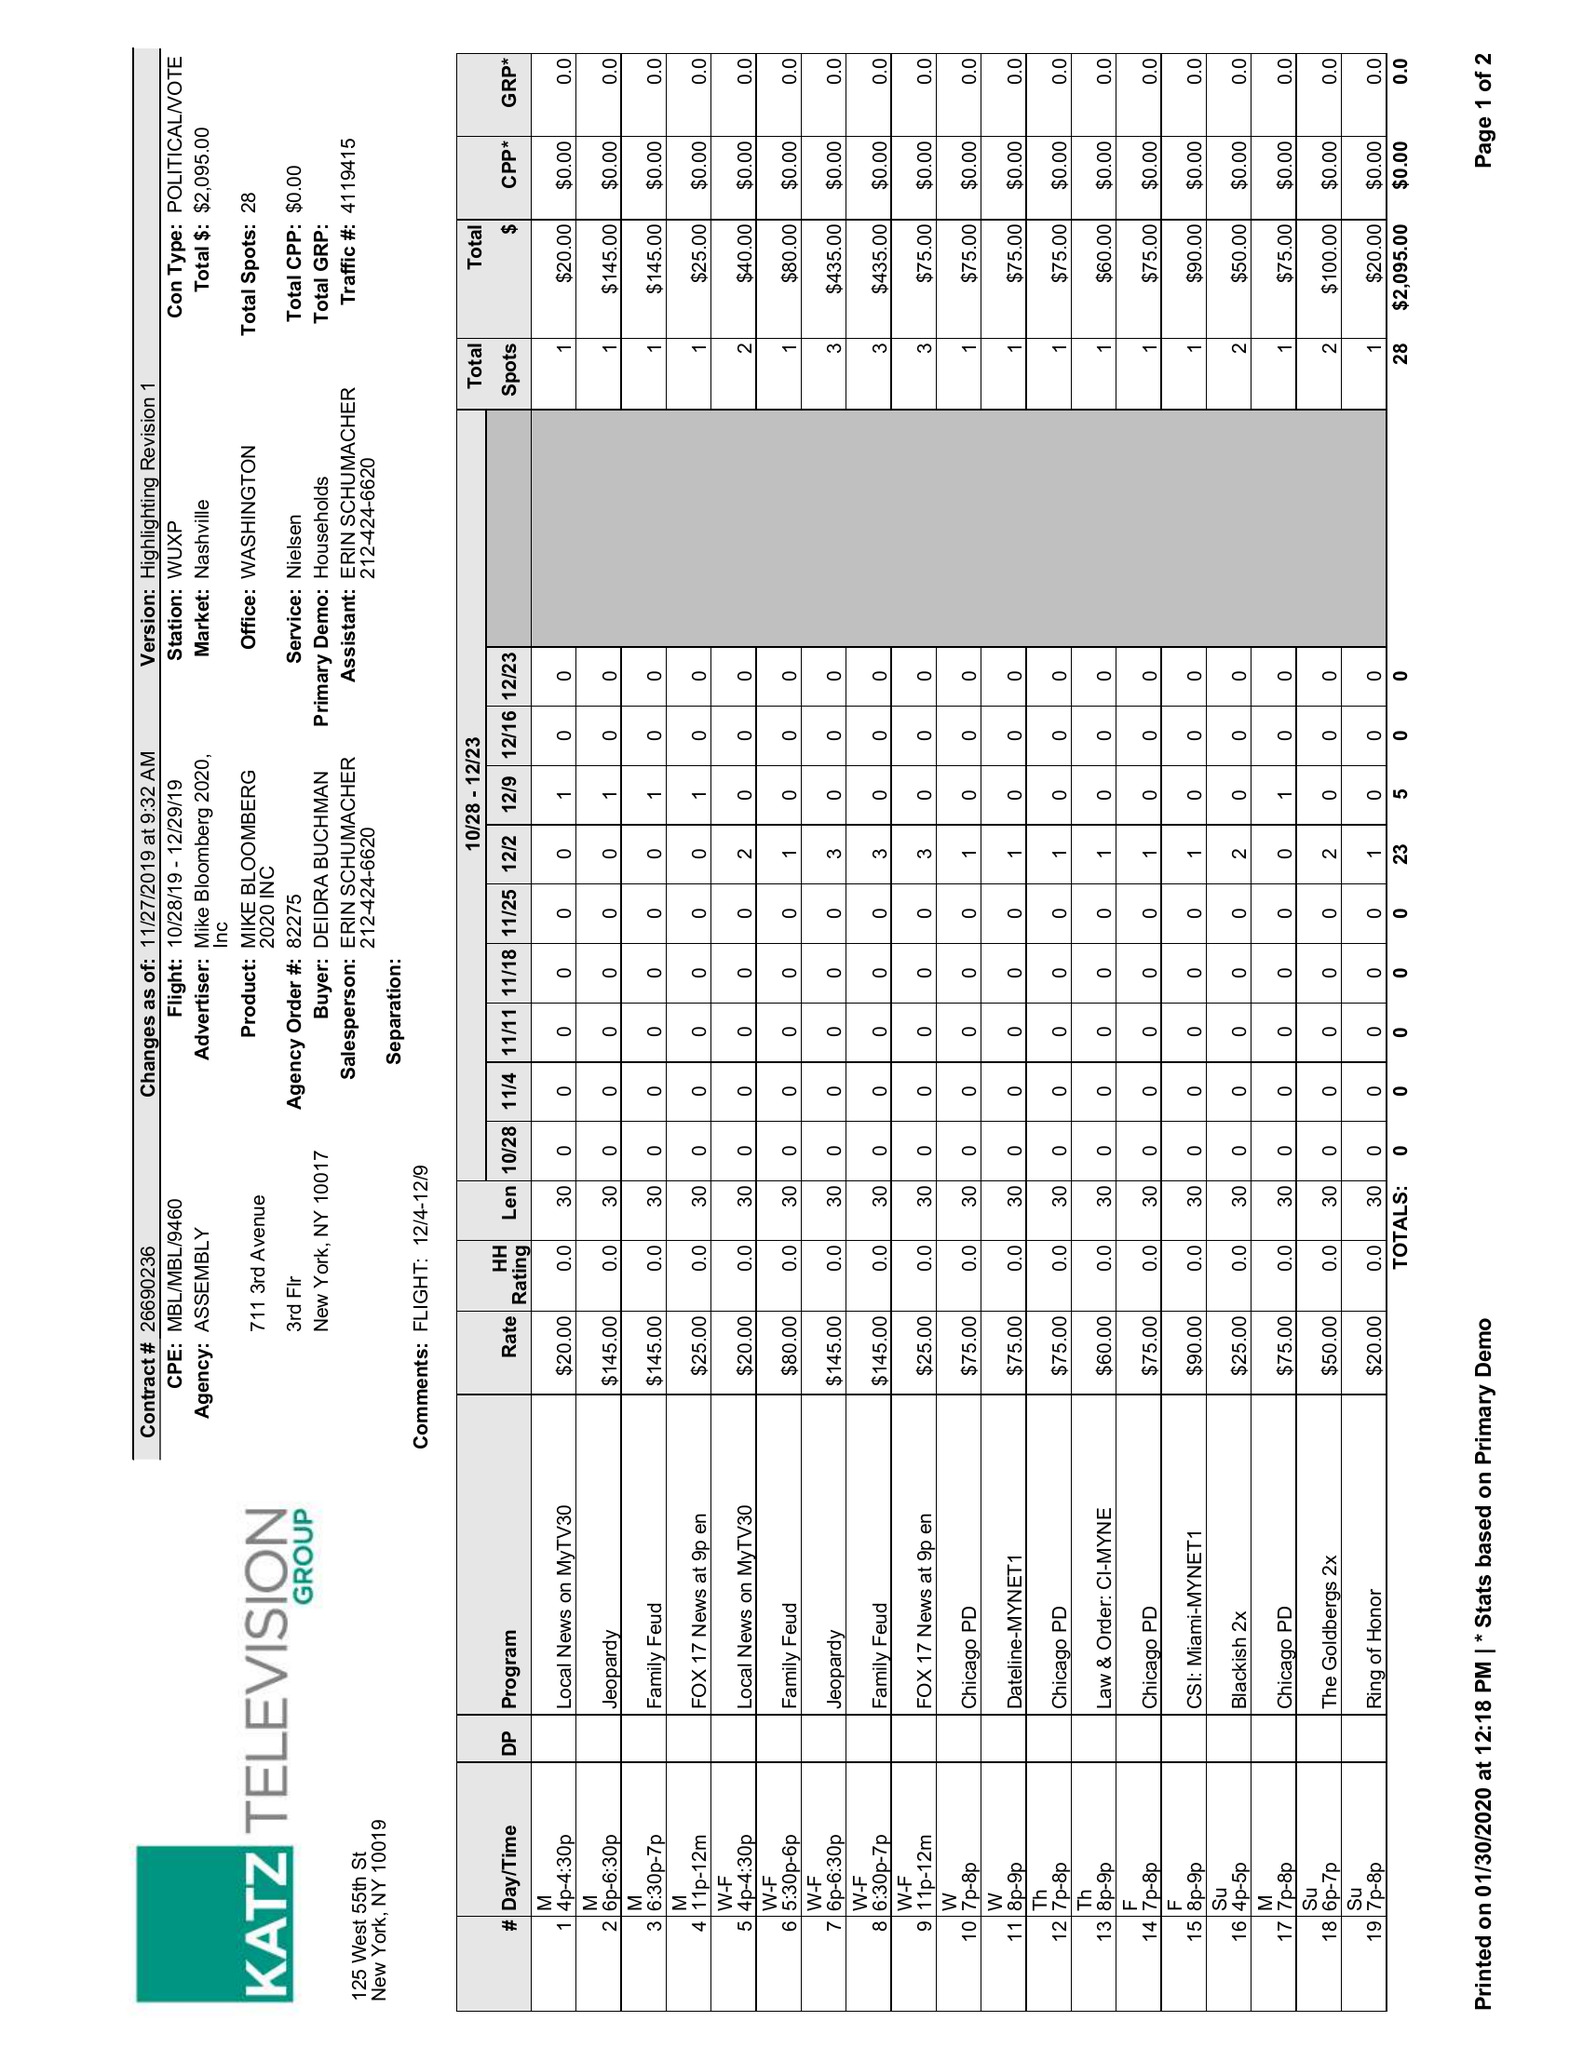What is the value for the contract_num?
Answer the question using a single word or phrase. 26690236 